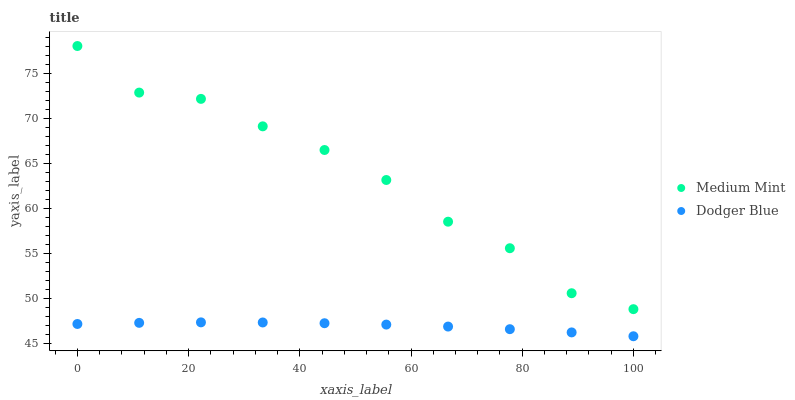Does Dodger Blue have the minimum area under the curve?
Answer yes or no. Yes. Does Medium Mint have the maximum area under the curve?
Answer yes or no. Yes. Does Dodger Blue have the maximum area under the curve?
Answer yes or no. No. Is Dodger Blue the smoothest?
Answer yes or no. Yes. Is Medium Mint the roughest?
Answer yes or no. Yes. Is Dodger Blue the roughest?
Answer yes or no. No. Does Dodger Blue have the lowest value?
Answer yes or no. Yes. Does Medium Mint have the highest value?
Answer yes or no. Yes. Does Dodger Blue have the highest value?
Answer yes or no. No. Is Dodger Blue less than Medium Mint?
Answer yes or no. Yes. Is Medium Mint greater than Dodger Blue?
Answer yes or no. Yes. Does Dodger Blue intersect Medium Mint?
Answer yes or no. No. 